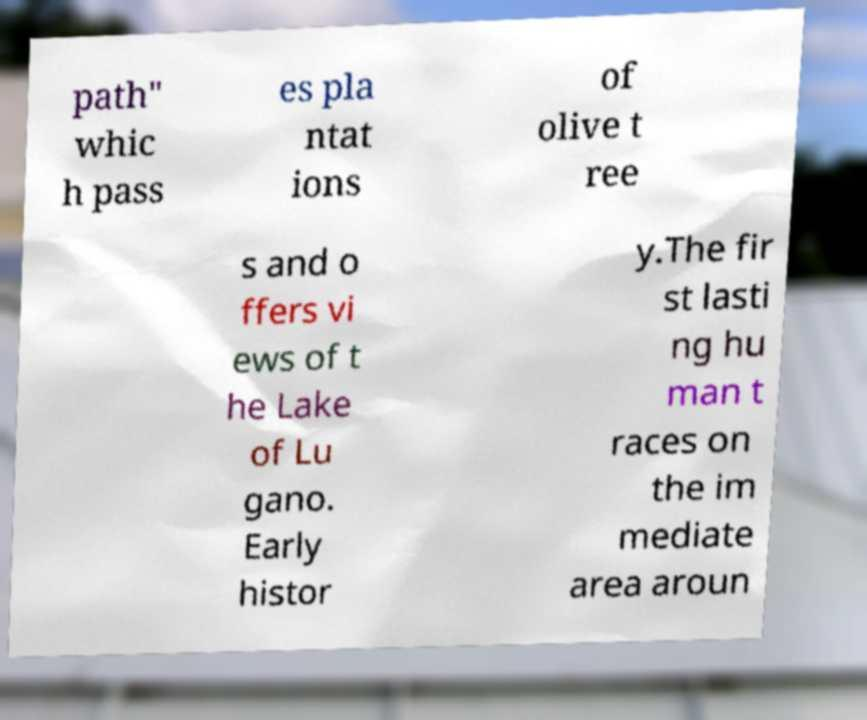Could you assist in decoding the text presented in this image and type it out clearly? path" whic h pass es pla ntat ions of olive t ree s and o ffers vi ews of t he Lake of Lu gano. Early histor y.The fir st lasti ng hu man t races on the im mediate area aroun 